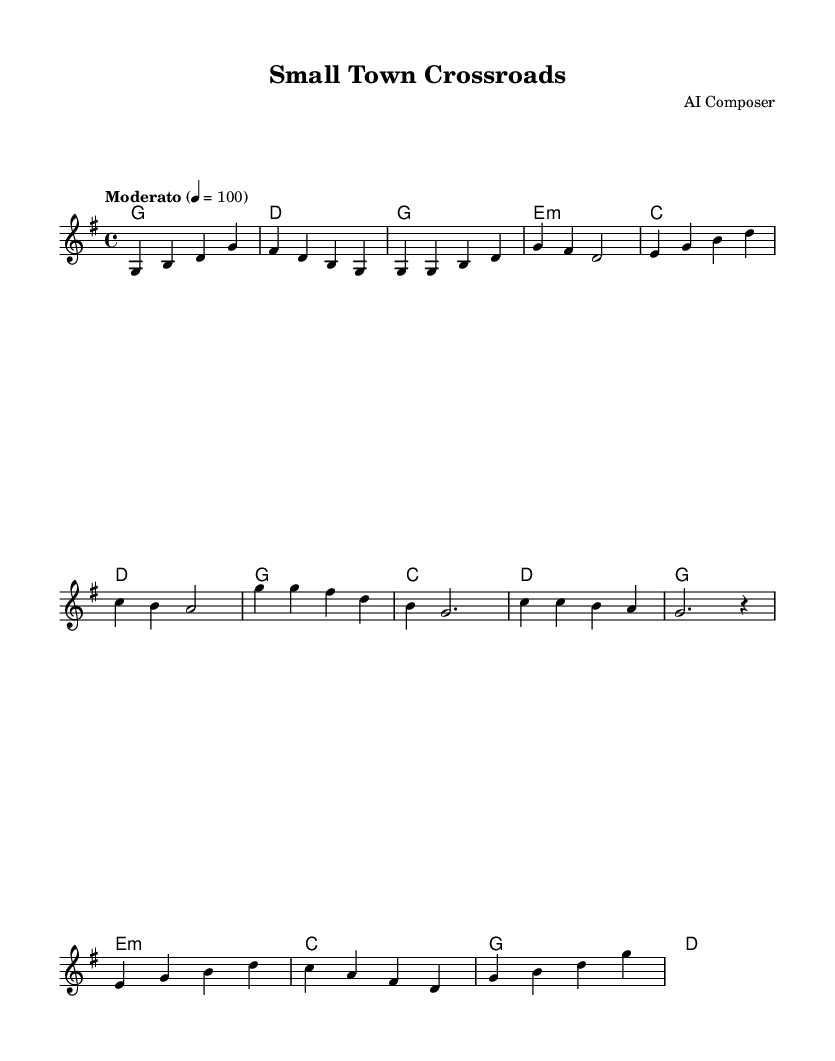What is the key signature of this music? The key signature is indicated by the sharp symbols on the staff. Looking at the music, there is one sharp (F#), which means it is in G major.
Answer: G major What is the time signature of the piece? The time signature is shown at the beginning of the music, where it indicates the number of beats in a measure. In this case, it reads 4/4, meaning there are four beats per measure.
Answer: 4/4 What is the tempo marking given in the sheet music? The tempo marking appears at the start of the score, where it specifies how fast the piece should be played. In this instance, it states "Moderato" with a metronome marking of 100 beats per minute.
Answer: Moderato, 100 How many measures are in the verse? To find the number of measures in the verse, we can count the segments between the bar lines in that section. The verse contains four measures.
Answer: 4 What type of chords are used in the bridge section? By analyzing the harmony written under the melody, we observe that the chords in the bridge (e minor, C, G, D) often reflect elements of folk music, as they are rooted in traditional chord progressions.
Answer: e minor, C, G, D Which section features a repeated musical phrase? The chorus section, denoted by distinct musical notations, repeats the melodic pattern in a memorable way, which is typical for a chorus structure.
Answer: Chorus What is the overall mood conveyed by the combination of melody and harmony? The combination of the joyful melody and simple harmonies creates a sense of nostalgia and community, characteristic of modern folk music that reflects small-town themes.
Answer: Nostalgia 